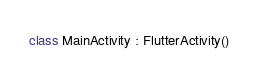<code> <loc_0><loc_0><loc_500><loc_500><_Kotlin_>class MainActivity : FlutterActivity()
</code> 